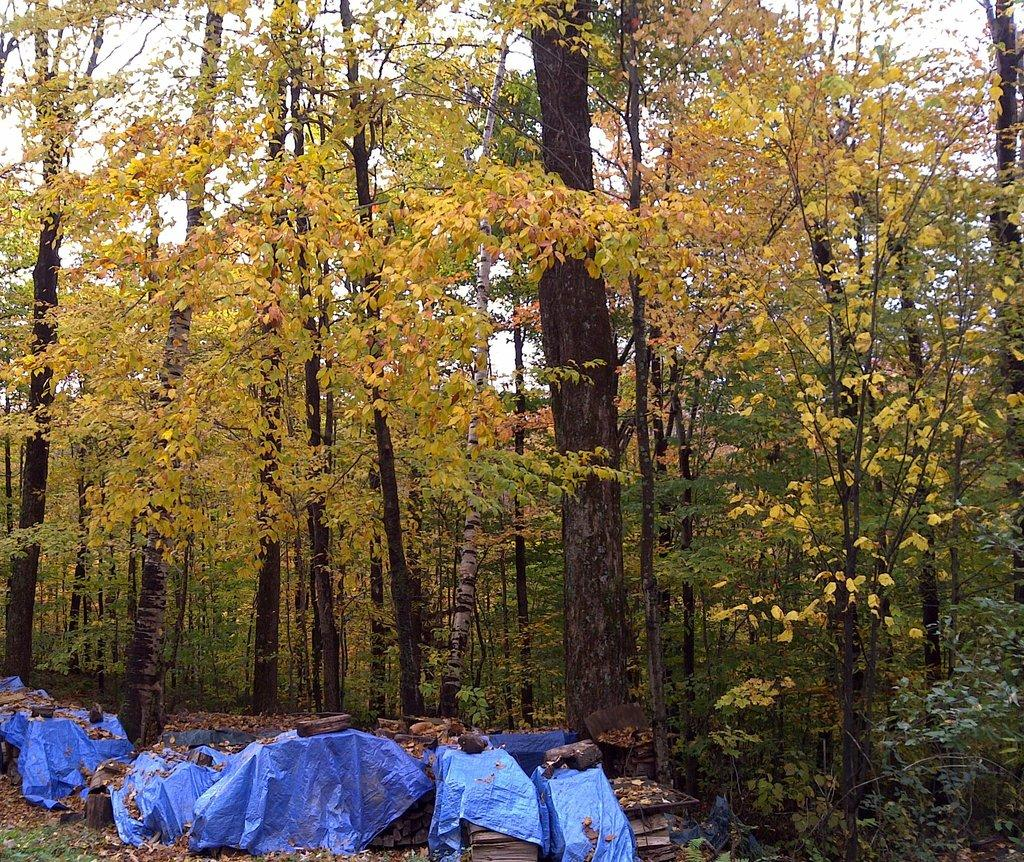What type of vegetation can be seen in the image? There is a group of trees in the image. What part of the natural environment is visible in the image? The sky is visible in the image. What might be protecting the objects in the image? The objects in the image are on plastic covers. What is the effect of the limit on the end of the image? There is no limit or end mentioned in the image, and therefore no effect can be determined. 